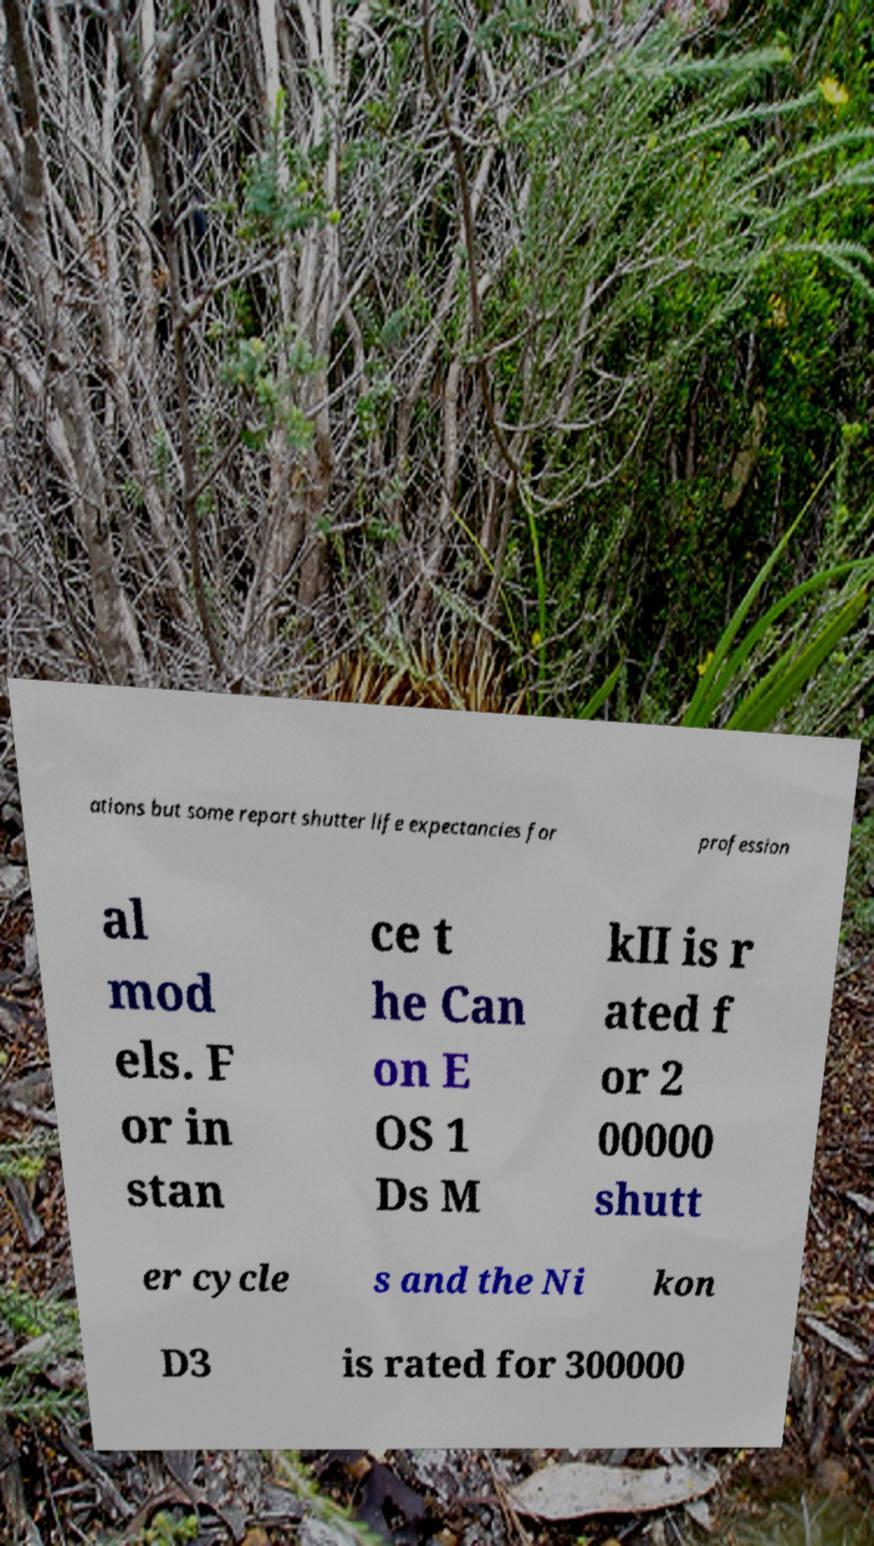Please read and relay the text visible in this image. What does it say? ations but some report shutter life expectancies for profession al mod els. F or in stan ce t he Can on E OS 1 Ds M kII is r ated f or 2 00000 shutt er cycle s and the Ni kon D3 is rated for 300000 